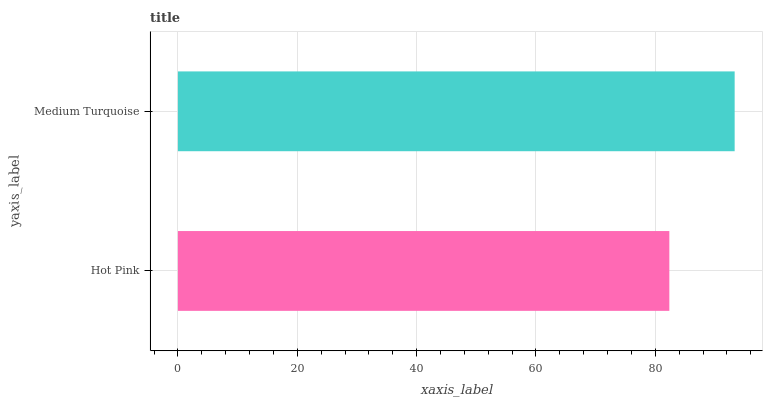Is Hot Pink the minimum?
Answer yes or no. Yes. Is Medium Turquoise the maximum?
Answer yes or no. Yes. Is Medium Turquoise the minimum?
Answer yes or no. No. Is Medium Turquoise greater than Hot Pink?
Answer yes or no. Yes. Is Hot Pink less than Medium Turquoise?
Answer yes or no. Yes. Is Hot Pink greater than Medium Turquoise?
Answer yes or no. No. Is Medium Turquoise less than Hot Pink?
Answer yes or no. No. Is Medium Turquoise the high median?
Answer yes or no. Yes. Is Hot Pink the low median?
Answer yes or no. Yes. Is Hot Pink the high median?
Answer yes or no. No. Is Medium Turquoise the low median?
Answer yes or no. No. 